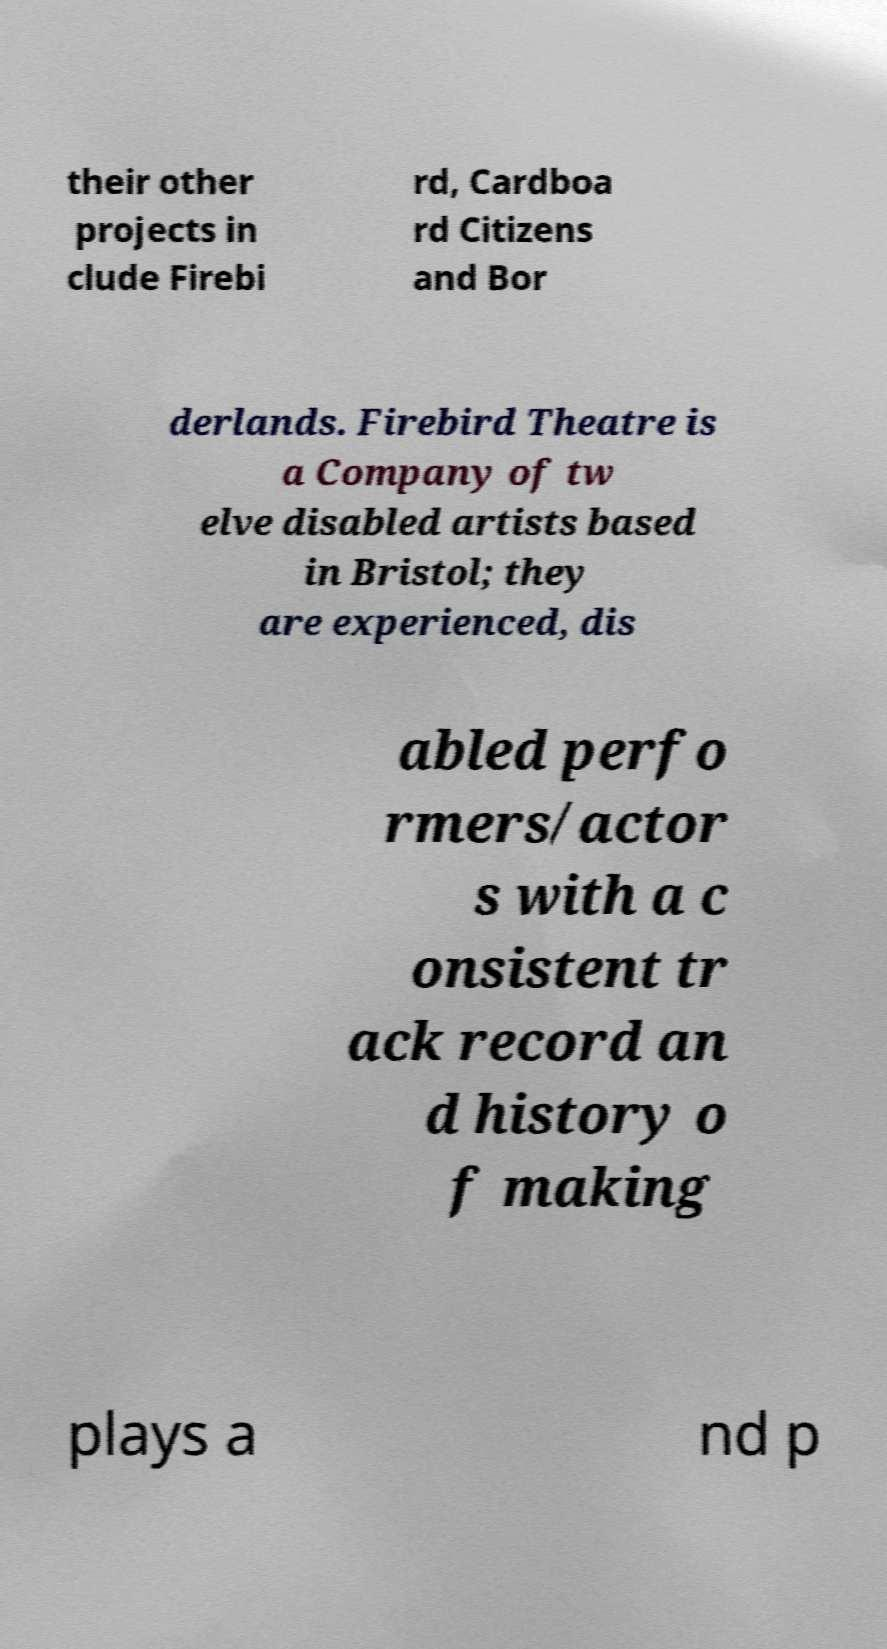Could you assist in decoding the text presented in this image and type it out clearly? their other projects in clude Firebi rd, Cardboa rd Citizens and Bor derlands. Firebird Theatre is a Company of tw elve disabled artists based in Bristol; they are experienced, dis abled perfo rmers/actor s with a c onsistent tr ack record an d history o f making plays a nd p 